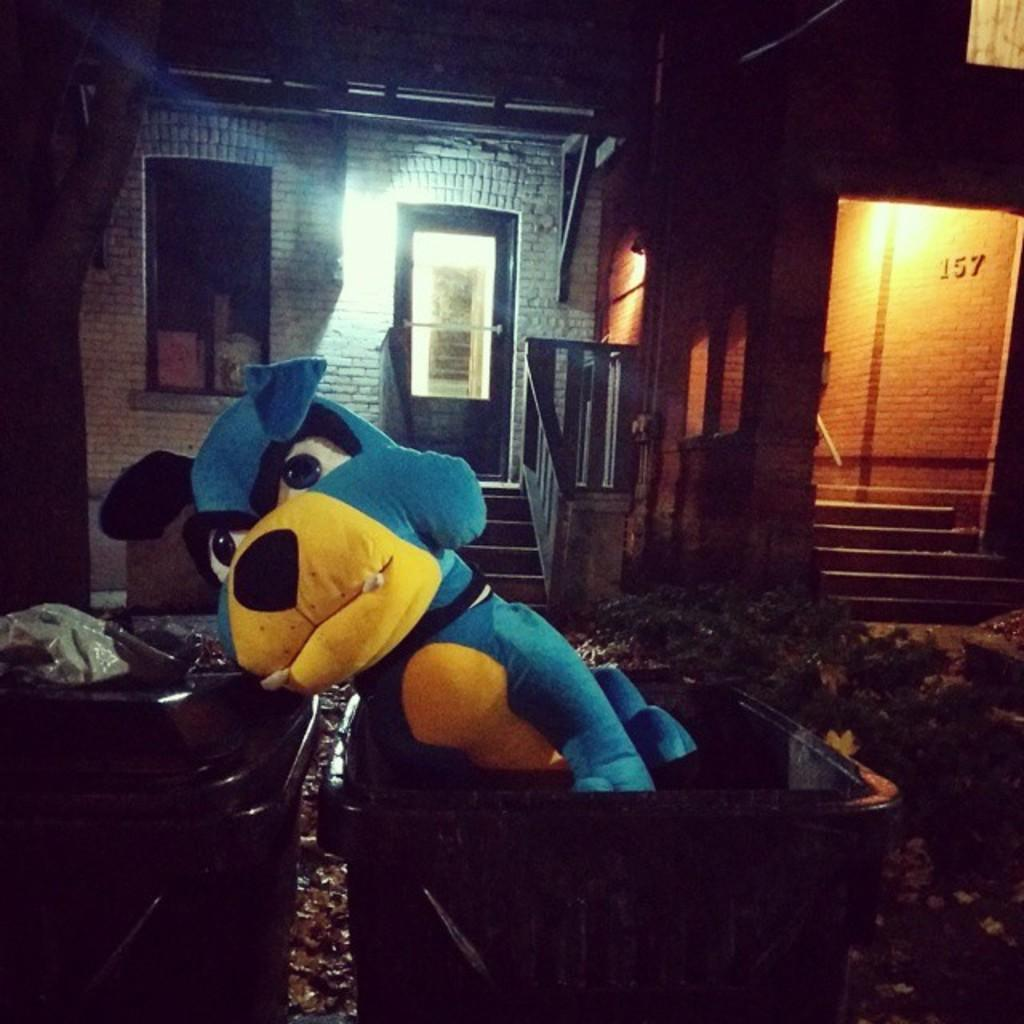What is inside the bin in the image? There is a toy in the bin. What can be seen in the background of the image? There is a shed and stairs visible in the background of the image. What type of account is being discussed in the image? There is no account being discussed in the image; it features a toy in a bin and a shed and stairs in the background. 